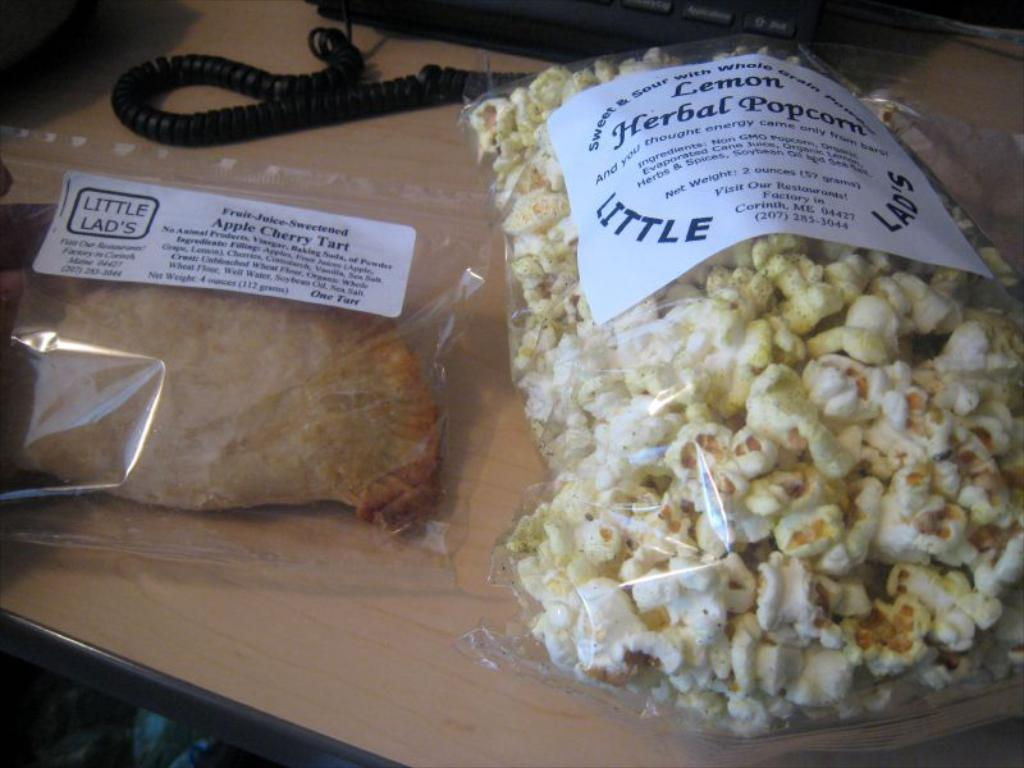What is the primary surface on which the objects are placed in the image? The objects are placed on a table. Can you describe the objects that are visible on the table? Unfortunately, the provided facts do not specify the objects on the table. However, we can still discuss the table itself. What might be the purpose of placing objects on a table? The purpose of placing objects on a table could be for display, storage, or use during an activity. How many circles can be seen on the table in the image? There is no mention of circles in the provided facts, so we cannot determine the number of circles on the table. 